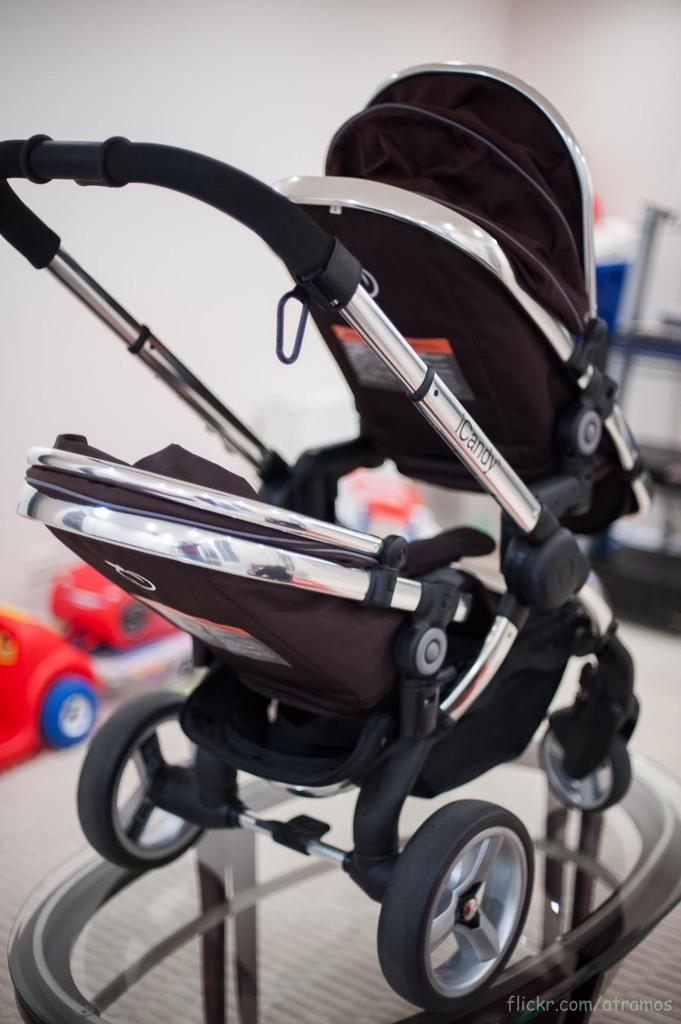What type of mobility aid is present in the image? There is a wheelchair in the image. What colors can be seen on the wheelchair? The wheelchair is black and silver in color. What type of toys are visible in the image? There are toy vehicles in the image. What color are the toy vehicles? The toy vehicles are red in color. What can be seen on the background of the image? There is a white wall visible in the image. What type of string is being used to connect the toy vehicles in the image? There is no string connecting the toy vehicles in the image; they are separate toys. 